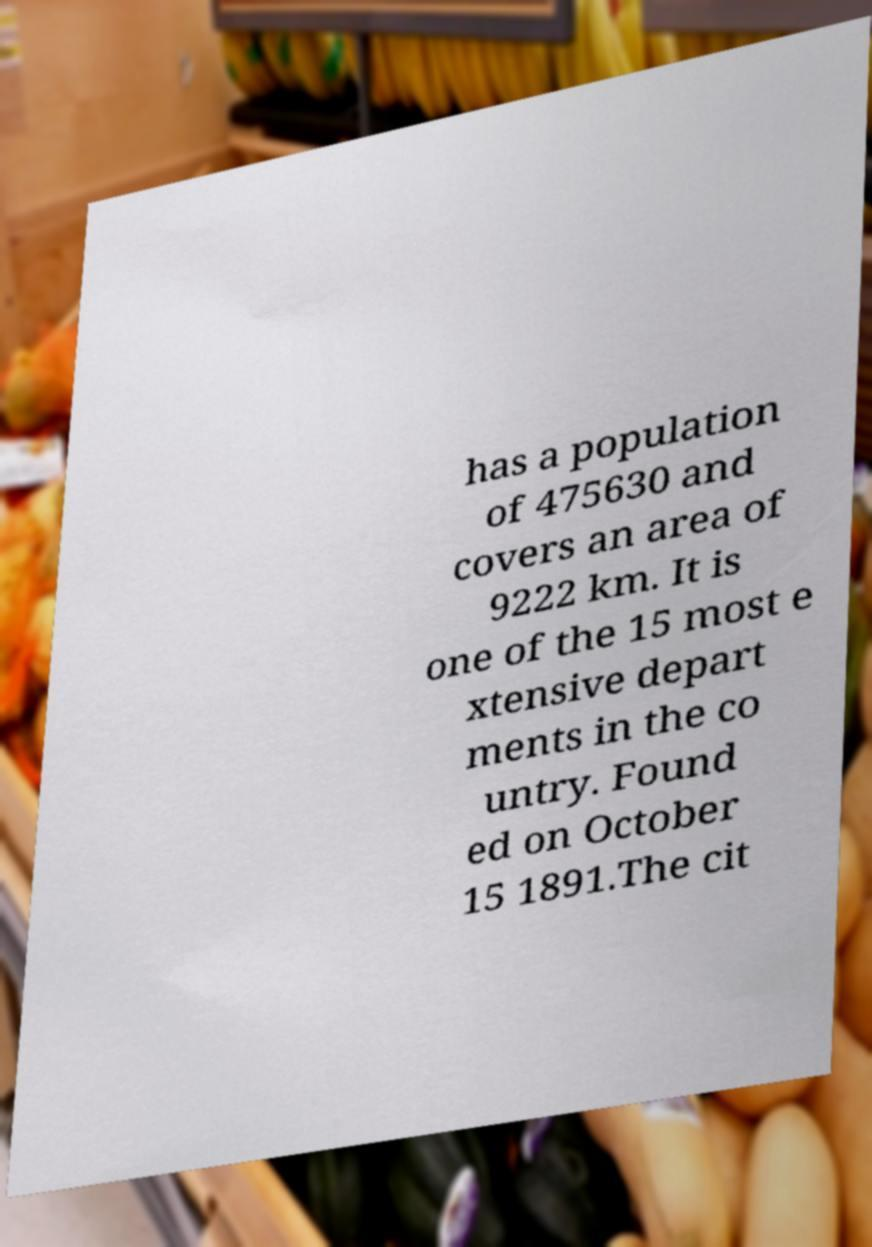For documentation purposes, I need the text within this image transcribed. Could you provide that? has a population of 475630 and covers an area of 9222 km. It is one of the 15 most e xtensive depart ments in the co untry. Found ed on October 15 1891.The cit 